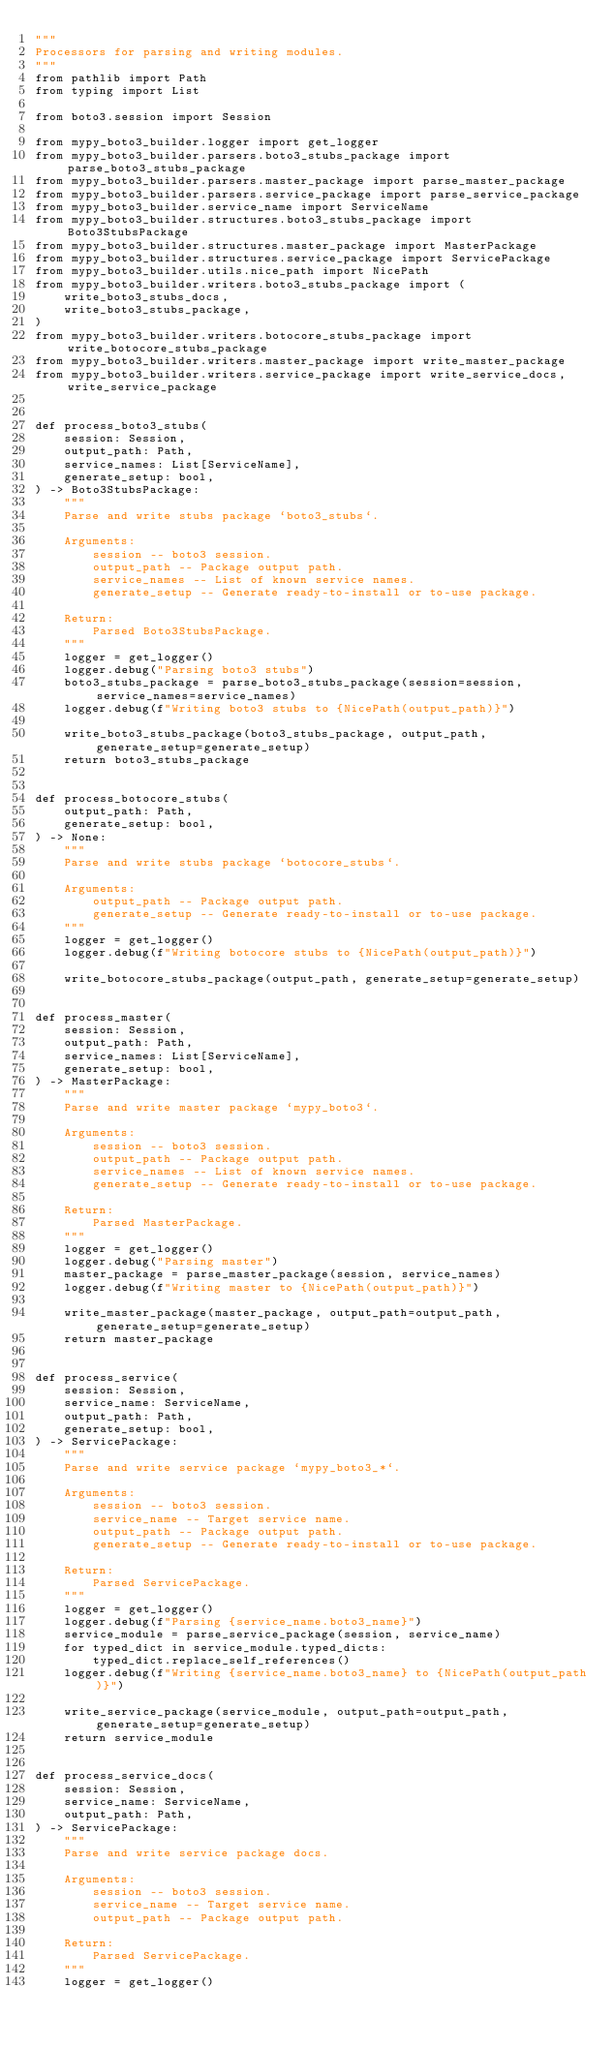Convert code to text. <code><loc_0><loc_0><loc_500><loc_500><_Python_>"""
Processors for parsing and writing modules.
"""
from pathlib import Path
from typing import List

from boto3.session import Session

from mypy_boto3_builder.logger import get_logger
from mypy_boto3_builder.parsers.boto3_stubs_package import parse_boto3_stubs_package
from mypy_boto3_builder.parsers.master_package import parse_master_package
from mypy_boto3_builder.parsers.service_package import parse_service_package
from mypy_boto3_builder.service_name import ServiceName
from mypy_boto3_builder.structures.boto3_stubs_package import Boto3StubsPackage
from mypy_boto3_builder.structures.master_package import MasterPackage
from mypy_boto3_builder.structures.service_package import ServicePackage
from mypy_boto3_builder.utils.nice_path import NicePath
from mypy_boto3_builder.writers.boto3_stubs_package import (
    write_boto3_stubs_docs,
    write_boto3_stubs_package,
)
from mypy_boto3_builder.writers.botocore_stubs_package import write_botocore_stubs_package
from mypy_boto3_builder.writers.master_package import write_master_package
from mypy_boto3_builder.writers.service_package import write_service_docs, write_service_package


def process_boto3_stubs(
    session: Session,
    output_path: Path,
    service_names: List[ServiceName],
    generate_setup: bool,
) -> Boto3StubsPackage:
    """
    Parse and write stubs package `boto3_stubs`.

    Arguments:
        session -- boto3 session.
        output_path -- Package output path.
        service_names -- List of known service names.
        generate_setup -- Generate ready-to-install or to-use package.

    Return:
        Parsed Boto3StubsPackage.
    """
    logger = get_logger()
    logger.debug("Parsing boto3 stubs")
    boto3_stubs_package = parse_boto3_stubs_package(session=session, service_names=service_names)
    logger.debug(f"Writing boto3 stubs to {NicePath(output_path)}")

    write_boto3_stubs_package(boto3_stubs_package, output_path, generate_setup=generate_setup)
    return boto3_stubs_package


def process_botocore_stubs(
    output_path: Path,
    generate_setup: bool,
) -> None:
    """
    Parse and write stubs package `botocore_stubs`.

    Arguments:
        output_path -- Package output path.
        generate_setup -- Generate ready-to-install or to-use package.
    """
    logger = get_logger()
    logger.debug(f"Writing botocore stubs to {NicePath(output_path)}")

    write_botocore_stubs_package(output_path, generate_setup=generate_setup)


def process_master(
    session: Session,
    output_path: Path,
    service_names: List[ServiceName],
    generate_setup: bool,
) -> MasterPackage:
    """
    Parse and write master package `mypy_boto3`.

    Arguments:
        session -- boto3 session.
        output_path -- Package output path.
        service_names -- List of known service names.
        generate_setup -- Generate ready-to-install or to-use package.

    Return:
        Parsed MasterPackage.
    """
    logger = get_logger()
    logger.debug("Parsing master")
    master_package = parse_master_package(session, service_names)
    logger.debug(f"Writing master to {NicePath(output_path)}")

    write_master_package(master_package, output_path=output_path, generate_setup=generate_setup)
    return master_package


def process_service(
    session: Session,
    service_name: ServiceName,
    output_path: Path,
    generate_setup: bool,
) -> ServicePackage:
    """
    Parse and write service package `mypy_boto3_*`.

    Arguments:
        session -- boto3 session.
        service_name -- Target service name.
        output_path -- Package output path.
        generate_setup -- Generate ready-to-install or to-use package.

    Return:
        Parsed ServicePackage.
    """
    logger = get_logger()
    logger.debug(f"Parsing {service_name.boto3_name}")
    service_module = parse_service_package(session, service_name)
    for typed_dict in service_module.typed_dicts:
        typed_dict.replace_self_references()
    logger.debug(f"Writing {service_name.boto3_name} to {NicePath(output_path)}")

    write_service_package(service_module, output_path=output_path, generate_setup=generate_setup)
    return service_module


def process_service_docs(
    session: Session,
    service_name: ServiceName,
    output_path: Path,
) -> ServicePackage:
    """
    Parse and write service package docs.

    Arguments:
        session -- boto3 session.
        service_name -- Target service name.
        output_path -- Package output path.

    Return:
        Parsed ServicePackage.
    """
    logger = get_logger()</code> 